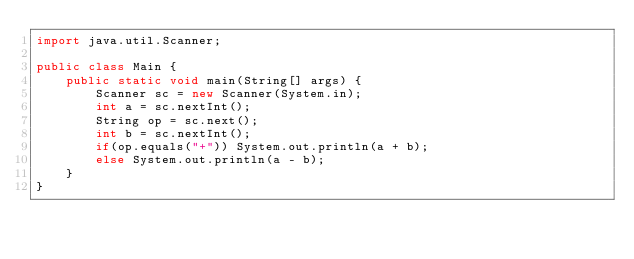<code> <loc_0><loc_0><loc_500><loc_500><_Java_>import java.util.Scanner;

public class Main {
    public static void main(String[] args) {
        Scanner sc = new Scanner(System.in);
        int a = sc.nextInt();
        String op = sc.next();
        int b = sc.nextInt();
        if(op.equals("+")) System.out.println(a + b);
        else System.out.println(a - b);
    }
}</code> 